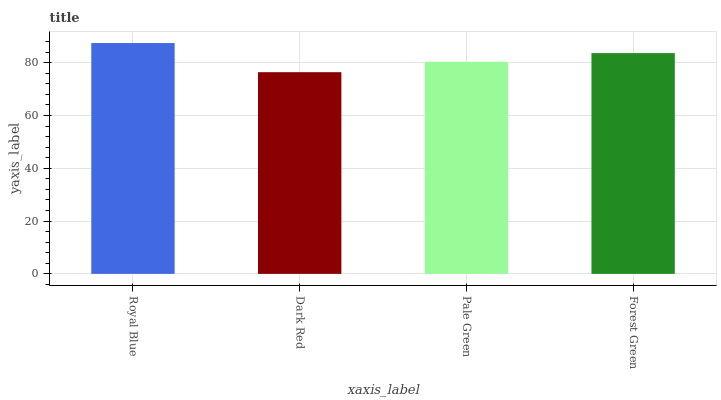Is Dark Red the minimum?
Answer yes or no. Yes. Is Royal Blue the maximum?
Answer yes or no. Yes. Is Pale Green the minimum?
Answer yes or no. No. Is Pale Green the maximum?
Answer yes or no. No. Is Pale Green greater than Dark Red?
Answer yes or no. Yes. Is Dark Red less than Pale Green?
Answer yes or no. Yes. Is Dark Red greater than Pale Green?
Answer yes or no. No. Is Pale Green less than Dark Red?
Answer yes or no. No. Is Forest Green the high median?
Answer yes or no. Yes. Is Pale Green the low median?
Answer yes or no. Yes. Is Dark Red the high median?
Answer yes or no. No. Is Forest Green the low median?
Answer yes or no. No. 